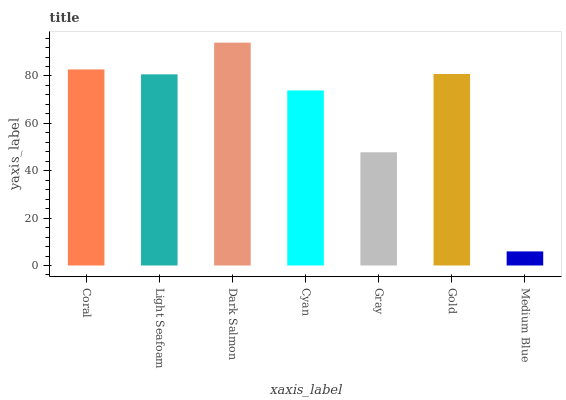Is Medium Blue the minimum?
Answer yes or no. Yes. Is Dark Salmon the maximum?
Answer yes or no. Yes. Is Light Seafoam the minimum?
Answer yes or no. No. Is Light Seafoam the maximum?
Answer yes or no. No. Is Coral greater than Light Seafoam?
Answer yes or no. Yes. Is Light Seafoam less than Coral?
Answer yes or no. Yes. Is Light Seafoam greater than Coral?
Answer yes or no. No. Is Coral less than Light Seafoam?
Answer yes or no. No. Is Light Seafoam the high median?
Answer yes or no. Yes. Is Light Seafoam the low median?
Answer yes or no. Yes. Is Dark Salmon the high median?
Answer yes or no. No. Is Cyan the low median?
Answer yes or no. No. 